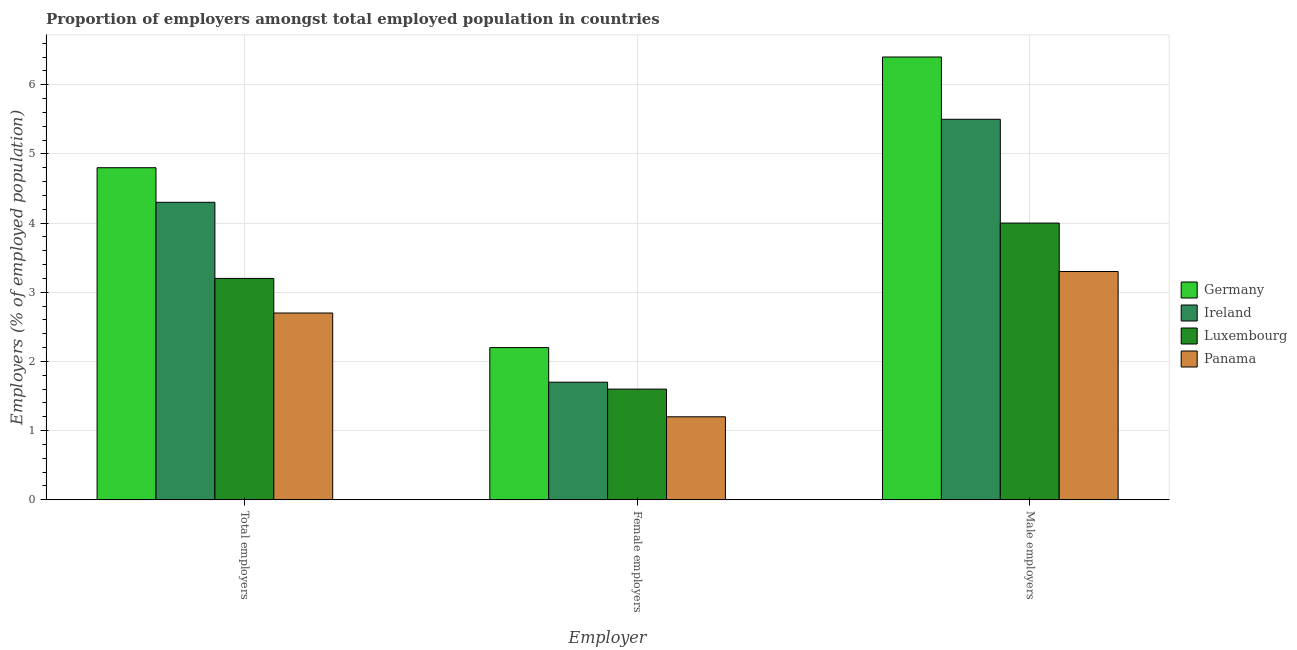How many groups of bars are there?
Offer a very short reply. 3. Are the number of bars per tick equal to the number of legend labels?
Your answer should be compact. Yes. How many bars are there on the 2nd tick from the right?
Make the answer very short. 4. What is the label of the 2nd group of bars from the left?
Keep it short and to the point. Female employers. What is the percentage of female employers in Panama?
Give a very brief answer. 1.2. Across all countries, what is the maximum percentage of male employers?
Your answer should be compact. 6.4. Across all countries, what is the minimum percentage of male employers?
Offer a very short reply. 3.3. In which country was the percentage of total employers minimum?
Your answer should be very brief. Panama. What is the total percentage of female employers in the graph?
Offer a very short reply. 6.7. What is the difference between the percentage of male employers in Panama and that in Germany?
Offer a very short reply. -3.1. What is the difference between the percentage of female employers in Germany and the percentage of male employers in Ireland?
Keep it short and to the point. -3.3. What is the average percentage of female employers per country?
Your answer should be very brief. 1.68. What is the difference between the percentage of male employers and percentage of total employers in Luxembourg?
Offer a terse response. 0.8. What is the ratio of the percentage of female employers in Panama to that in Luxembourg?
Provide a short and direct response. 0.75. Is the percentage of female employers in Panama less than that in Germany?
Your response must be concise. Yes. Is the difference between the percentage of male employers in Ireland and Panama greater than the difference between the percentage of total employers in Ireland and Panama?
Provide a short and direct response. Yes. What is the difference between the highest and the second highest percentage of total employers?
Offer a terse response. 0.5. What is the difference between the highest and the lowest percentage of female employers?
Provide a short and direct response. 1. In how many countries, is the percentage of male employers greater than the average percentage of male employers taken over all countries?
Ensure brevity in your answer.  2. Is the sum of the percentage of female employers in Luxembourg and Ireland greater than the maximum percentage of male employers across all countries?
Your answer should be compact. No. What does the 3rd bar from the right in Total employers represents?
Your answer should be compact. Ireland. How many bars are there?
Keep it short and to the point. 12. Are all the bars in the graph horizontal?
Ensure brevity in your answer.  No. How many countries are there in the graph?
Offer a terse response. 4. Does the graph contain any zero values?
Provide a short and direct response. No. Does the graph contain grids?
Provide a succinct answer. Yes. What is the title of the graph?
Provide a succinct answer. Proportion of employers amongst total employed population in countries. What is the label or title of the X-axis?
Offer a very short reply. Employer. What is the label or title of the Y-axis?
Give a very brief answer. Employers (% of employed population). What is the Employers (% of employed population) in Germany in Total employers?
Give a very brief answer. 4.8. What is the Employers (% of employed population) in Ireland in Total employers?
Your answer should be very brief. 4.3. What is the Employers (% of employed population) in Luxembourg in Total employers?
Provide a succinct answer. 3.2. What is the Employers (% of employed population) of Panama in Total employers?
Offer a very short reply. 2.7. What is the Employers (% of employed population) in Germany in Female employers?
Make the answer very short. 2.2. What is the Employers (% of employed population) of Ireland in Female employers?
Offer a terse response. 1.7. What is the Employers (% of employed population) of Luxembourg in Female employers?
Keep it short and to the point. 1.6. What is the Employers (% of employed population) of Panama in Female employers?
Offer a very short reply. 1.2. What is the Employers (% of employed population) in Germany in Male employers?
Give a very brief answer. 6.4. What is the Employers (% of employed population) in Ireland in Male employers?
Keep it short and to the point. 5.5. What is the Employers (% of employed population) of Panama in Male employers?
Your answer should be compact. 3.3. Across all Employer, what is the maximum Employers (% of employed population) in Germany?
Ensure brevity in your answer.  6.4. Across all Employer, what is the maximum Employers (% of employed population) in Luxembourg?
Offer a terse response. 4. Across all Employer, what is the maximum Employers (% of employed population) in Panama?
Your answer should be very brief. 3.3. Across all Employer, what is the minimum Employers (% of employed population) in Germany?
Ensure brevity in your answer.  2.2. Across all Employer, what is the minimum Employers (% of employed population) in Ireland?
Offer a very short reply. 1.7. Across all Employer, what is the minimum Employers (% of employed population) of Luxembourg?
Ensure brevity in your answer.  1.6. Across all Employer, what is the minimum Employers (% of employed population) of Panama?
Make the answer very short. 1.2. What is the difference between the Employers (% of employed population) in Germany in Total employers and that in Female employers?
Your answer should be very brief. 2.6. What is the difference between the Employers (% of employed population) in Luxembourg in Total employers and that in Male employers?
Provide a succinct answer. -0.8. What is the difference between the Employers (% of employed population) of Panama in Total employers and that in Male employers?
Make the answer very short. -0.6. What is the difference between the Employers (% of employed population) in Ireland in Female employers and that in Male employers?
Offer a very short reply. -3.8. What is the difference between the Employers (% of employed population) in Luxembourg in Female employers and that in Male employers?
Offer a terse response. -2.4. What is the difference between the Employers (% of employed population) of Germany in Total employers and the Employers (% of employed population) of Luxembourg in Female employers?
Provide a succinct answer. 3.2. What is the difference between the Employers (% of employed population) in Germany in Total employers and the Employers (% of employed population) in Panama in Female employers?
Ensure brevity in your answer.  3.6. What is the difference between the Employers (% of employed population) of Luxembourg in Total employers and the Employers (% of employed population) of Panama in Female employers?
Offer a very short reply. 2. What is the difference between the Employers (% of employed population) of Germany in Total employers and the Employers (% of employed population) of Luxembourg in Male employers?
Ensure brevity in your answer.  0.8. What is the difference between the Employers (% of employed population) of Ireland in Total employers and the Employers (% of employed population) of Luxembourg in Male employers?
Make the answer very short. 0.3. What is the difference between the Employers (% of employed population) of Ireland in Total employers and the Employers (% of employed population) of Panama in Male employers?
Offer a terse response. 1. What is the difference between the Employers (% of employed population) in Germany in Female employers and the Employers (% of employed population) in Panama in Male employers?
Your response must be concise. -1.1. What is the difference between the Employers (% of employed population) in Ireland in Female employers and the Employers (% of employed population) in Panama in Male employers?
Offer a very short reply. -1.6. What is the average Employers (% of employed population) in Germany per Employer?
Give a very brief answer. 4.47. What is the average Employers (% of employed population) of Ireland per Employer?
Provide a short and direct response. 3.83. What is the average Employers (% of employed population) in Luxembourg per Employer?
Provide a short and direct response. 2.93. What is the difference between the Employers (% of employed population) of Germany and Employers (% of employed population) of Ireland in Total employers?
Offer a very short reply. 0.5. What is the difference between the Employers (% of employed population) of Germany and Employers (% of employed population) of Luxembourg in Total employers?
Offer a terse response. 1.6. What is the difference between the Employers (% of employed population) of Germany and Employers (% of employed population) of Panama in Total employers?
Keep it short and to the point. 2.1. What is the difference between the Employers (% of employed population) in Ireland and Employers (% of employed population) in Luxembourg in Total employers?
Give a very brief answer. 1.1. What is the difference between the Employers (% of employed population) in Germany and Employers (% of employed population) in Luxembourg in Female employers?
Provide a short and direct response. 0.6. What is the difference between the Employers (% of employed population) of Germany and Employers (% of employed population) of Ireland in Male employers?
Your answer should be very brief. 0.9. What is the difference between the Employers (% of employed population) of Ireland and Employers (% of employed population) of Panama in Male employers?
Give a very brief answer. 2.2. What is the ratio of the Employers (% of employed population) of Germany in Total employers to that in Female employers?
Provide a short and direct response. 2.18. What is the ratio of the Employers (% of employed population) of Ireland in Total employers to that in Female employers?
Keep it short and to the point. 2.53. What is the ratio of the Employers (% of employed population) in Luxembourg in Total employers to that in Female employers?
Make the answer very short. 2. What is the ratio of the Employers (% of employed population) in Panama in Total employers to that in Female employers?
Keep it short and to the point. 2.25. What is the ratio of the Employers (% of employed population) of Ireland in Total employers to that in Male employers?
Your answer should be compact. 0.78. What is the ratio of the Employers (% of employed population) of Luxembourg in Total employers to that in Male employers?
Make the answer very short. 0.8. What is the ratio of the Employers (% of employed population) in Panama in Total employers to that in Male employers?
Ensure brevity in your answer.  0.82. What is the ratio of the Employers (% of employed population) of Germany in Female employers to that in Male employers?
Keep it short and to the point. 0.34. What is the ratio of the Employers (% of employed population) of Ireland in Female employers to that in Male employers?
Offer a terse response. 0.31. What is the ratio of the Employers (% of employed population) in Panama in Female employers to that in Male employers?
Ensure brevity in your answer.  0.36. What is the difference between the highest and the second highest Employers (% of employed population) in Panama?
Offer a very short reply. 0.6. What is the difference between the highest and the lowest Employers (% of employed population) of Ireland?
Provide a short and direct response. 3.8. What is the difference between the highest and the lowest Employers (% of employed population) in Panama?
Your answer should be compact. 2.1. 